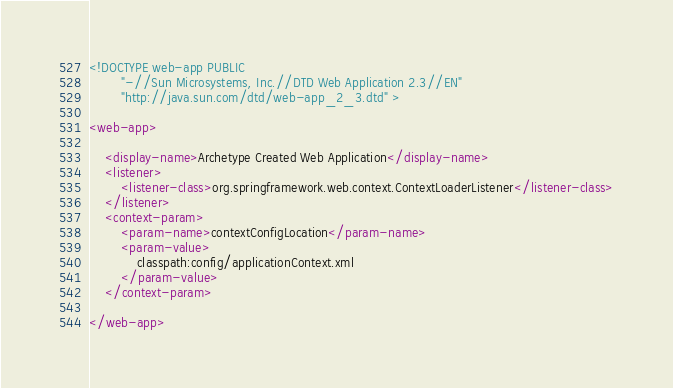Convert code to text. <code><loc_0><loc_0><loc_500><loc_500><_XML_><!DOCTYPE web-app PUBLIC
        "-//Sun Microsystems, Inc.//DTD Web Application 2.3//EN"
        "http://java.sun.com/dtd/web-app_2_3.dtd" >

<web-app>

    <display-name>Archetype Created Web Application</display-name>
    <listener>
        <listener-class>org.springframework.web.context.ContextLoaderListener</listener-class>
    </listener>
    <context-param>
        <param-name>contextConfigLocation</param-name>
        <param-value>
            classpath:config/applicationContext.xml
        </param-value>
    </context-param>

</web-app>
</code> 